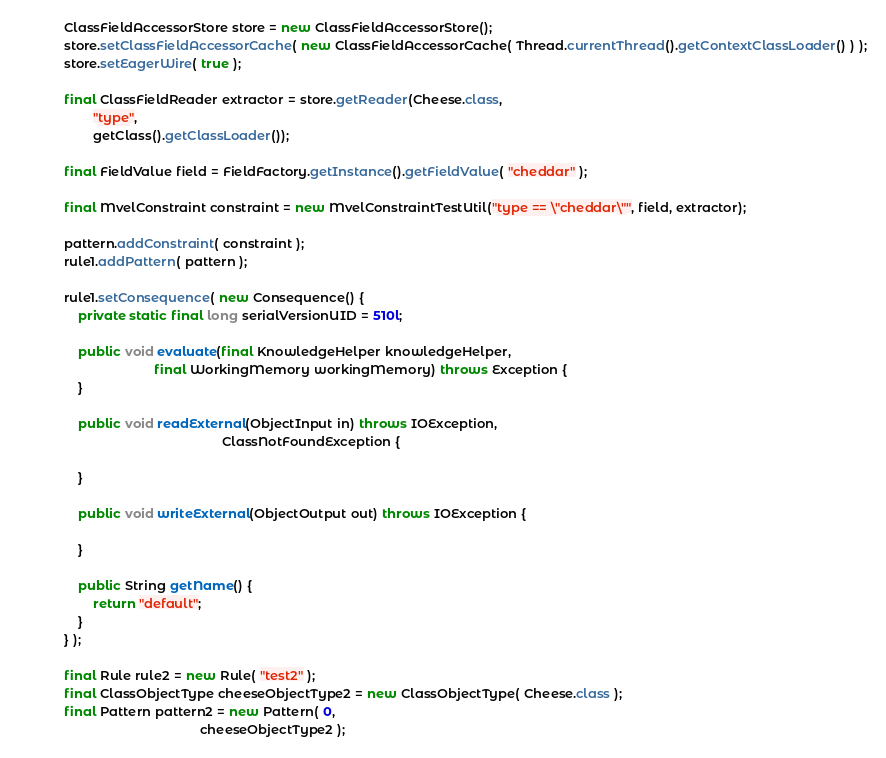Convert code to text. <code><loc_0><loc_0><loc_500><loc_500><_Java_>        ClassFieldAccessorStore store = new ClassFieldAccessorStore();
        store.setClassFieldAccessorCache( new ClassFieldAccessorCache( Thread.currentThread().getContextClassLoader() ) );
        store.setEagerWire( true );

        final ClassFieldReader extractor = store.getReader(Cheese.class,
                "type",
                getClass().getClassLoader());

        final FieldValue field = FieldFactory.getInstance().getFieldValue( "cheddar" );

        final MvelConstraint constraint = new MvelConstraintTestUtil("type == \"cheddar\"", field, extractor);

        pattern.addConstraint( constraint );
        rule1.addPattern( pattern );

        rule1.setConsequence( new Consequence() {
            private static final long serialVersionUID = 510l;

            public void evaluate(final KnowledgeHelper knowledgeHelper,
                                 final WorkingMemory workingMemory) throws Exception {
            }

            public void readExternal(ObjectInput in) throws IOException,
                                                    ClassNotFoundException {

            }

            public void writeExternal(ObjectOutput out) throws IOException {

            }
            
            public String getName() {
                return "default";
            }
        } );

        final Rule rule2 = new Rule( "test2" );
        final ClassObjectType cheeseObjectType2 = new ClassObjectType( Cheese.class );
        final Pattern pattern2 = new Pattern( 0,
                                              cheeseObjectType2 );
</code> 